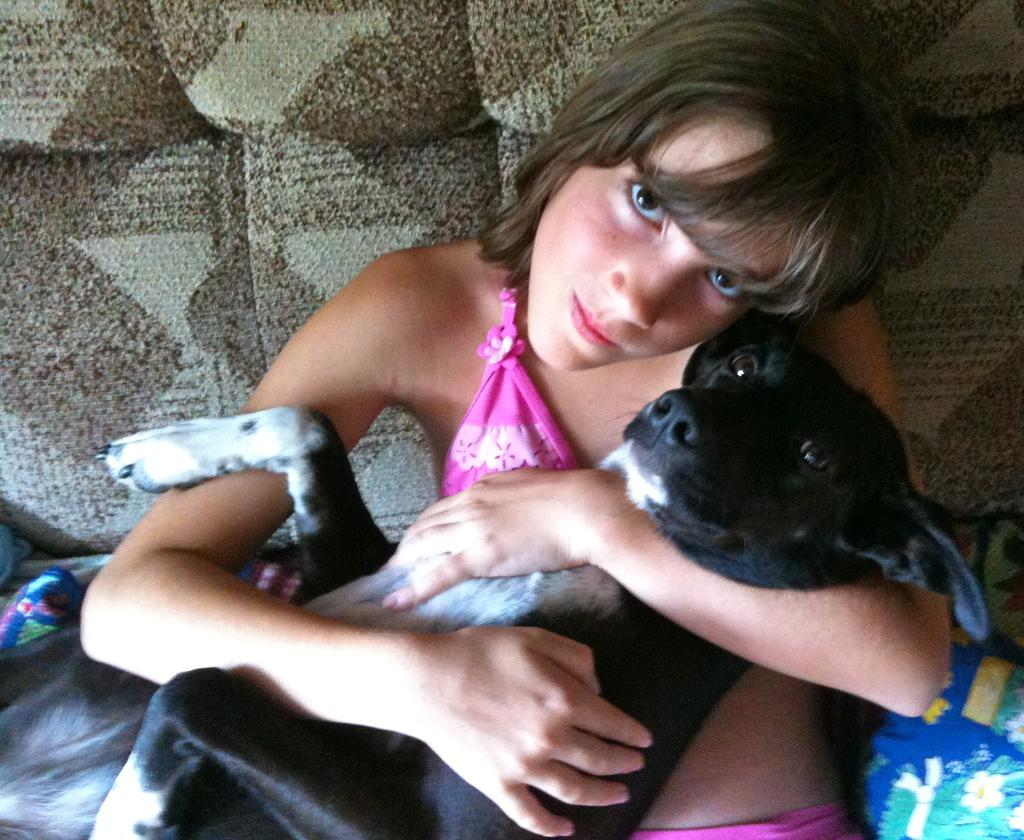Who is the main subject in the image? There is a lady in the image. What is the lady holding in the image? The lady is holding a black dog. What type of comb is the lady using to drive the shock in the image? There is no comb, driving, or shock present in the image. The lady is simply holding a black dog. 